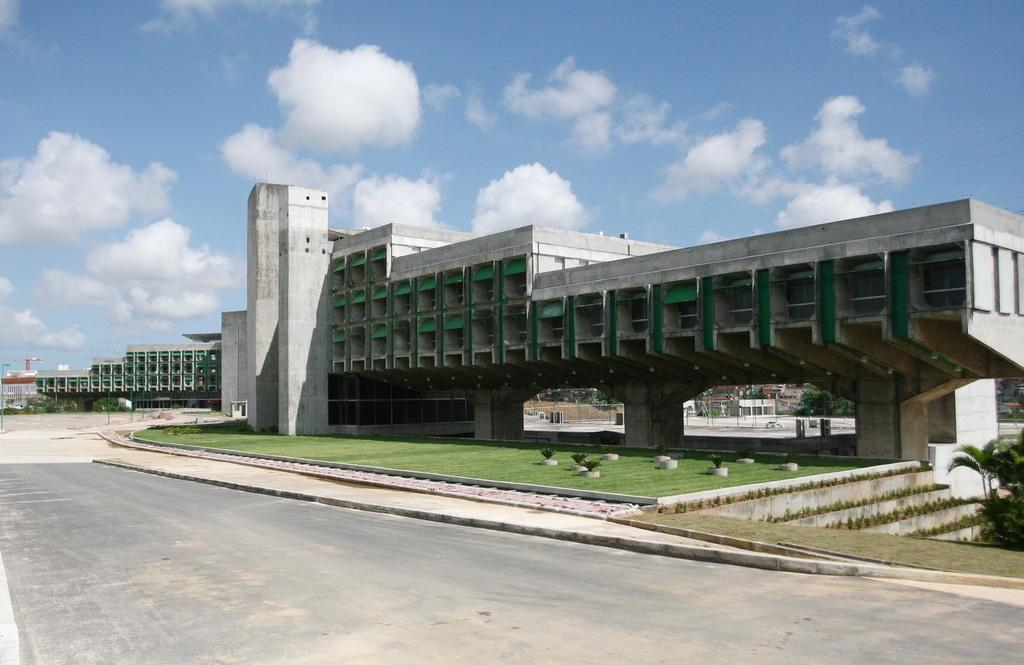What type of structures can be seen in the image? There are buildings in the image. What type of vegetation is present in the image? There are trees and grass in the image. What type of pathway can be seen in the image? There is a road in the image. What is visible in the background of the image? The sky is visible in the background of the image. What can be observed in the sky? Clouds are present in the sky. Can you tell me how many muscles are visible on the side of the building in the image? There are no muscles visible on the side of the building in the image, as buildings do not have muscles. Who is the creator of the clouds in the image? The clouds in the image are a natural weather phenomenon and do not have a specific creator. 